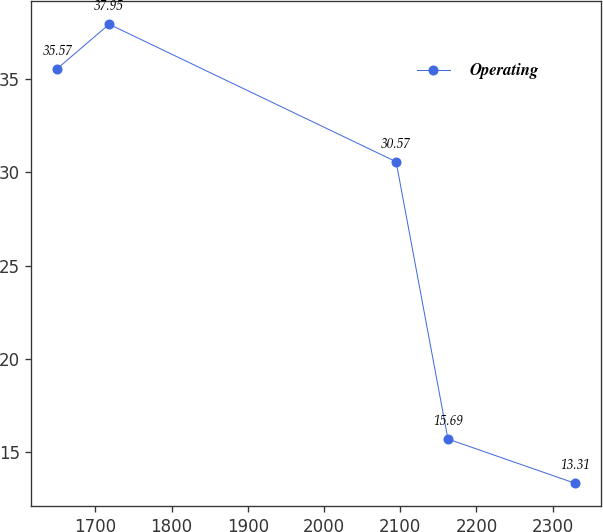Convert chart. <chart><loc_0><loc_0><loc_500><loc_500><line_chart><ecel><fcel>Operating<nl><fcel>1650.14<fcel>35.57<nl><fcel>1718.09<fcel>37.95<nl><fcel>2094.57<fcel>30.57<nl><fcel>2162.52<fcel>15.69<nl><fcel>2329.62<fcel>13.31<nl></chart> 